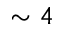Convert formula to latex. <formula><loc_0><loc_0><loc_500><loc_500>\sim 4</formula> 